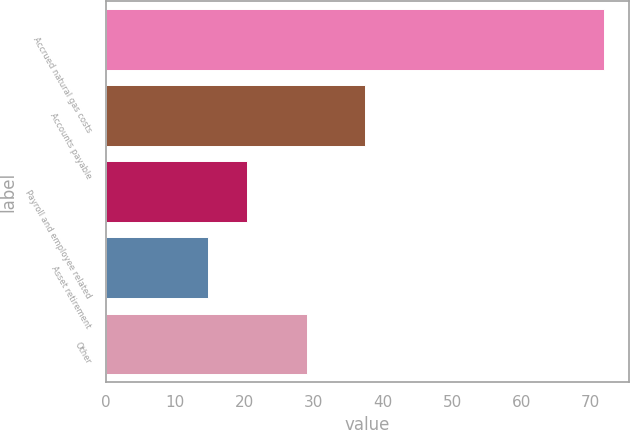<chart> <loc_0><loc_0><loc_500><loc_500><bar_chart><fcel>Accrued natural gas costs<fcel>Accounts payable<fcel>Payroll and employee related<fcel>Asset retirement<fcel>Other<nl><fcel>71.9<fcel>37.4<fcel>20.42<fcel>14.7<fcel>29<nl></chart> 